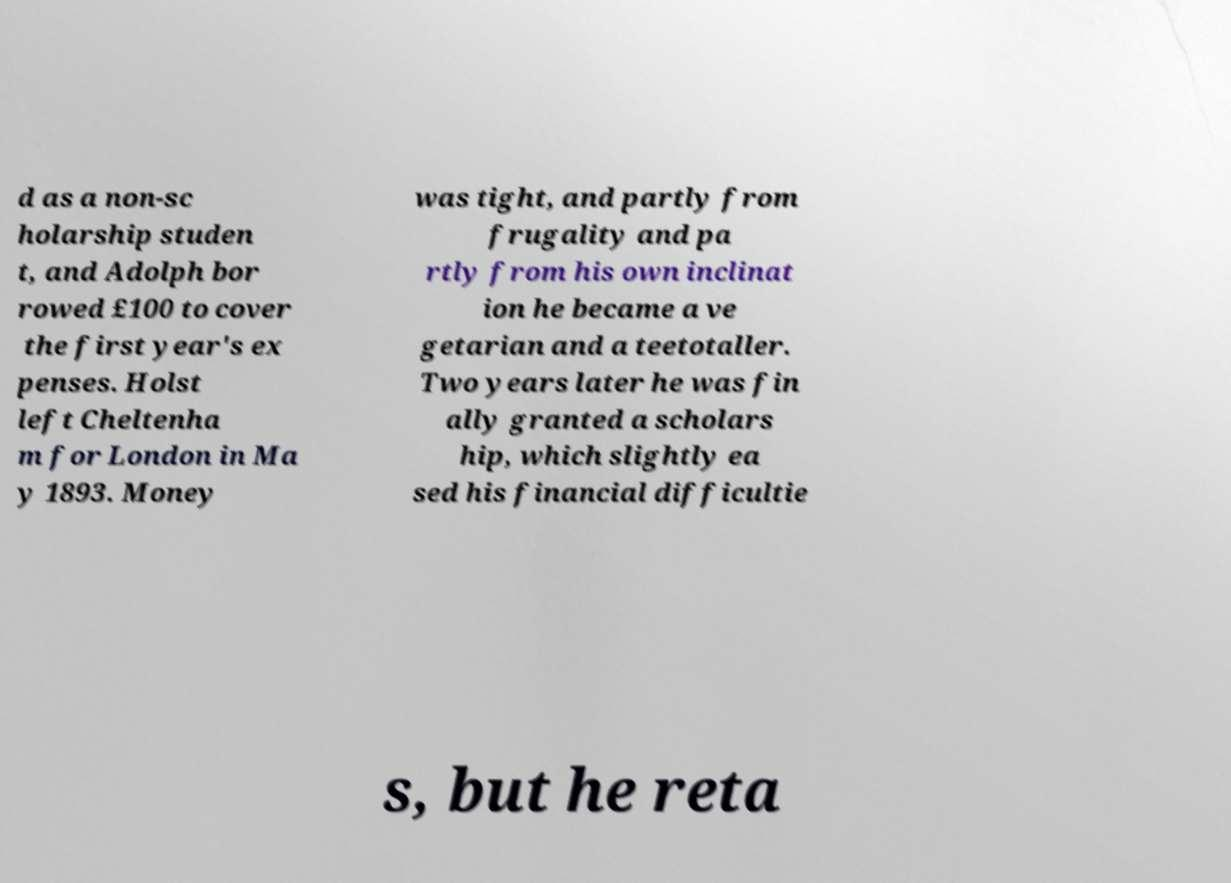Please identify and transcribe the text found in this image. d as a non-sc holarship studen t, and Adolph bor rowed £100 to cover the first year's ex penses. Holst left Cheltenha m for London in Ma y 1893. Money was tight, and partly from frugality and pa rtly from his own inclinat ion he became a ve getarian and a teetotaller. Two years later he was fin ally granted a scholars hip, which slightly ea sed his financial difficultie s, but he reta 